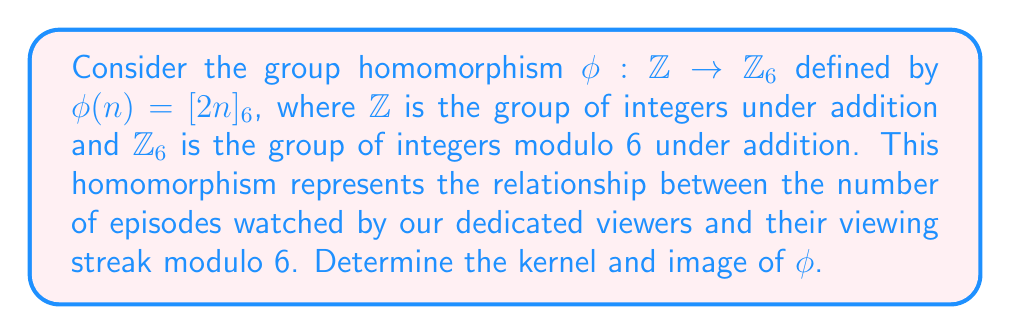Can you solve this math problem? Let's approach this step-by-step:

1) First, recall the definitions:
   - The kernel of a group homomorphism $\phi: G \to H$ is the set of all elements in G that map to the identity element in H.
   - The image of a group homomorphism $\phi: G \to H$ is the set of all elements in H that are mapped to by some element in G.

2) In this case, the identity element in $\mathbb{Z}_6$ is $[0]_6$.

3) To find the kernel, we need to solve the equation:
   $\phi(n) = [2n]_6 = [0]_6$
   
   This is equivalent to solving:
   $2n \equiv 0 \pmod{6}$
   
   The smallest positive solution is $n = 3$, as $2(3) = 6 \equiv 0 \pmod{6}$

4) Therefore, the kernel consists of all multiples of 3:
   $\text{ker}(\phi) = \{3k : k \in \mathbb{Z}\} = 3\mathbb{Z}$

5) To find the image, we need to consider all possible values of $[2n]_6$:
   - When $n = 0$, $\phi(0) = [0]_6$
   - When $n = 1$, $\phi(1) = [2]_6$
   - When $n = 2$, $\phi(2) = [4]_6$
   - When $n = 3$, $\phi(3) = [0]_6$
   - When $n = 4$, $\phi(4) = [2]_6$
   - When $n = 5$, $\phi(5) = [4]_6$

6) We see that the image consists of $[0]_6$, $[2]_6$, and $[4]_6$.

Therefore, $\text{Im}(\phi) = \{[0]_6, [2]_6, [4]_6\}$.
Answer: Kernel: $\text{ker}(\phi) = 3\mathbb{Z} = \{3k : k \in \mathbb{Z}\}$
Image: $\text{Im}(\phi) = \{[0]_6, [2]_6, [4]_6\}$ 